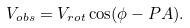<formula> <loc_0><loc_0><loc_500><loc_500>V _ { o b s } = V _ { r o t } \cos ( \phi - P A ) .</formula> 